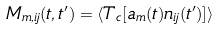Convert formula to latex. <formula><loc_0><loc_0><loc_500><loc_500>M _ { m , i j } ( t , t ^ { \prime } ) = \langle T _ { c } [ a _ { m } ( t ) n _ { i j } ( t ^ { \prime } ) ] \rangle</formula> 